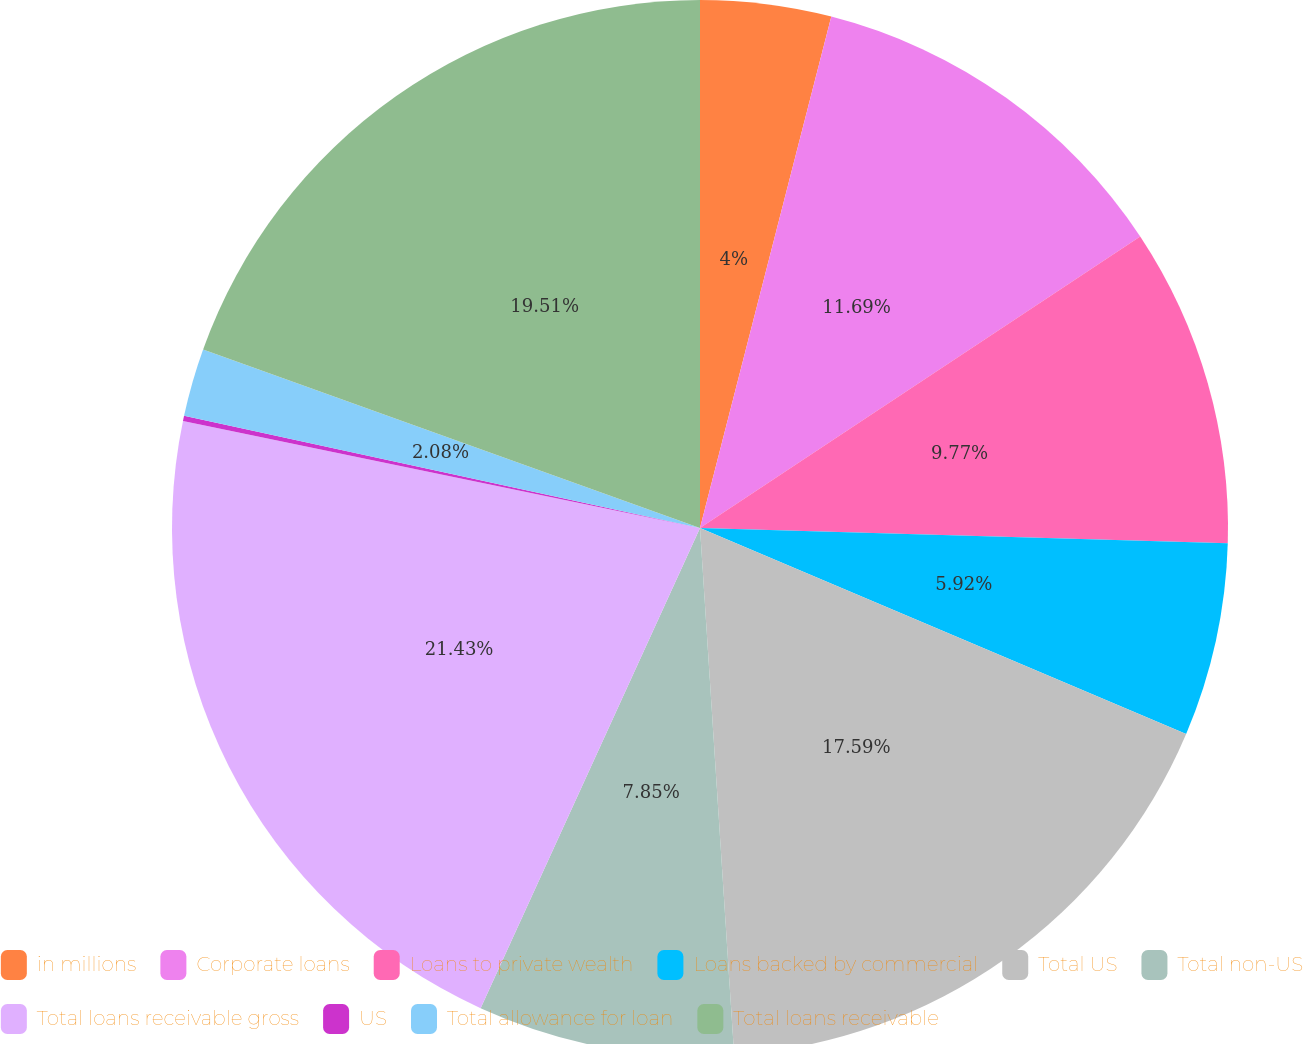<chart> <loc_0><loc_0><loc_500><loc_500><pie_chart><fcel>in millions<fcel>Corporate loans<fcel>Loans to private wealth<fcel>Loans backed by commercial<fcel>Total US<fcel>Total non-US<fcel>Total loans receivable gross<fcel>US<fcel>Total allowance for loan<fcel>Total loans receivable<nl><fcel>4.0%<fcel>11.69%<fcel>9.77%<fcel>5.92%<fcel>17.59%<fcel>7.85%<fcel>21.43%<fcel>0.16%<fcel>2.08%<fcel>19.51%<nl></chart> 